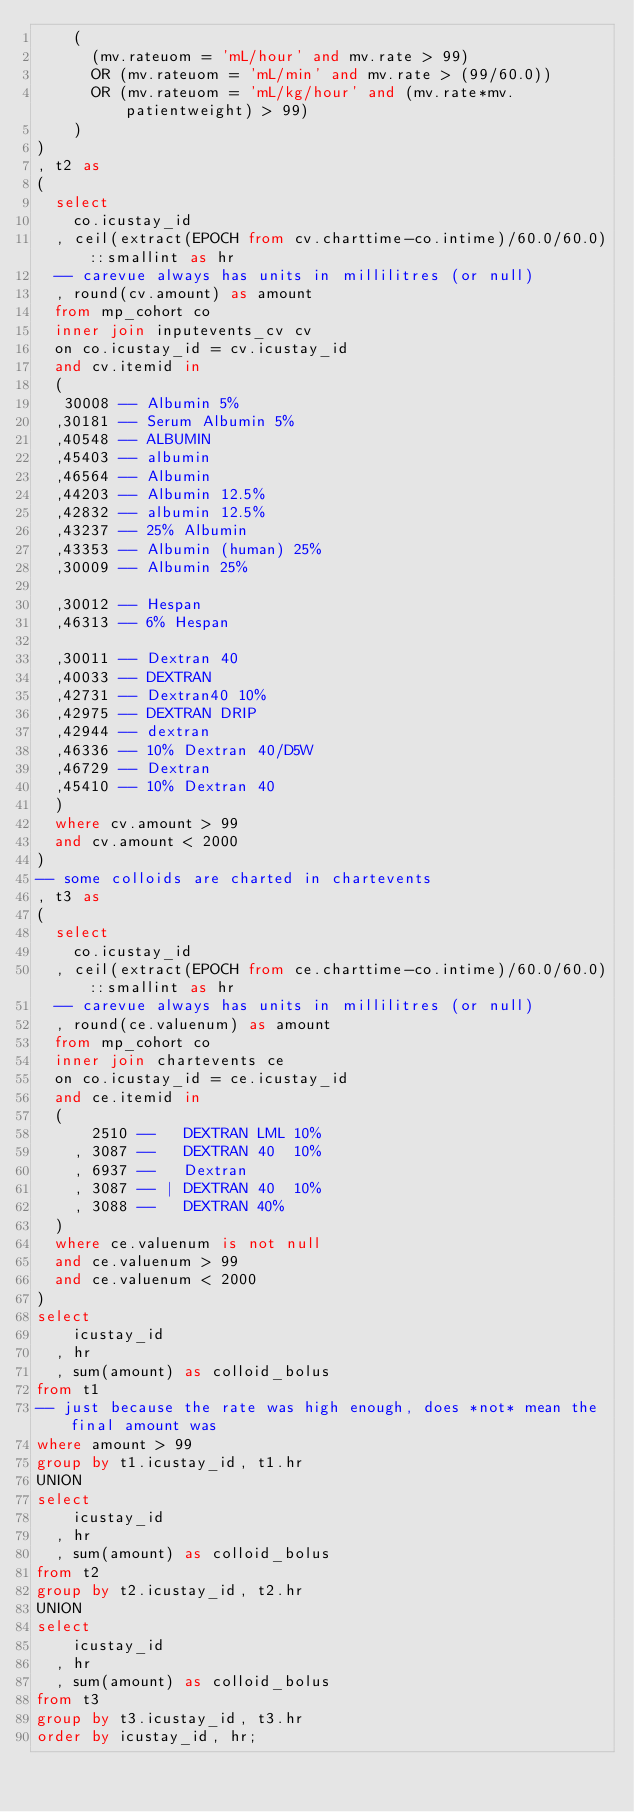Convert code to text. <code><loc_0><loc_0><loc_500><loc_500><_SQL_>    (
      (mv.rateuom = 'mL/hour' and mv.rate > 99)
      OR (mv.rateuom = 'mL/min' and mv.rate > (99/60.0))
      OR (mv.rateuom = 'mL/kg/hour' and (mv.rate*mv.patientweight) > 99)
    )
)
, t2 as
(
  select
    co.icustay_id
  , ceil(extract(EPOCH from cv.charttime-co.intime)/60.0/60.0)::smallint as hr
  -- carevue always has units in millilitres (or null)
  , round(cv.amount) as amount
  from mp_cohort co
  inner join inputevents_cv cv
  on co.icustay_id = cv.icustay_id
  and cv.itemid in
  (
   30008 --	Albumin 5%
  ,30181 -- Serum Albumin 5%
  ,40548 --	ALBUMIN
  ,45403 --	albumin
  ,46564 -- Albumin
  ,44203 --	Albumin 12.5%
  ,42832 --	albumin 12.5%
  ,43237 -- 25% Albumin
  ,43353 -- Albumin (human) 25%
  ,30009 --	Albumin 25%

  ,30012 --	Hespan
  ,46313 --	6% Hespan

  ,30011 -- Dextran 40
  ,40033 --	DEXTRAN
  ,42731 -- Dextran40 10%
  ,42975 --	DEXTRAN DRIP
  ,42944 --	dextran
  ,46336 --	10% Dextran 40/D5W
  ,46729 --	Dextran
  ,45410 --	10% Dextran 40
  )
  where cv.amount > 99
  and cv.amount < 2000
)
-- some colloids are charted in chartevents
, t3 as
(
  select
    co.icustay_id
  , ceil(extract(EPOCH from ce.charttime-co.intime)/60.0/60.0)::smallint as hr
  -- carevue always has units in millilitres (or null)
  , round(ce.valuenum) as amount
  from mp_cohort co
  inner join chartevents ce
  on co.icustay_id = ce.icustay_id
  and ce.itemid in
  (
      2510 --	DEXTRAN LML 10%
    , 3087 --	DEXTRAN 40  10%
    , 6937 --	Dextran
    , 3087 -- | DEXTRAN 40  10%
    , 3088 --	DEXTRAN 40%
  )
  where ce.valuenum is not null
  and ce.valuenum > 99
  and ce.valuenum < 2000
)
select
    icustay_id
  , hr
  , sum(amount) as colloid_bolus
from t1
-- just because the rate was high enough, does *not* mean the final amount was
where amount > 99
group by t1.icustay_id, t1.hr
UNION
select
    icustay_id
  , hr
  , sum(amount) as colloid_bolus
from t2
group by t2.icustay_id, t2.hr
UNION
select
    icustay_id
  , hr
  , sum(amount) as colloid_bolus
from t3
group by t3.icustay_id, t3.hr
order by icustay_id, hr;
</code> 